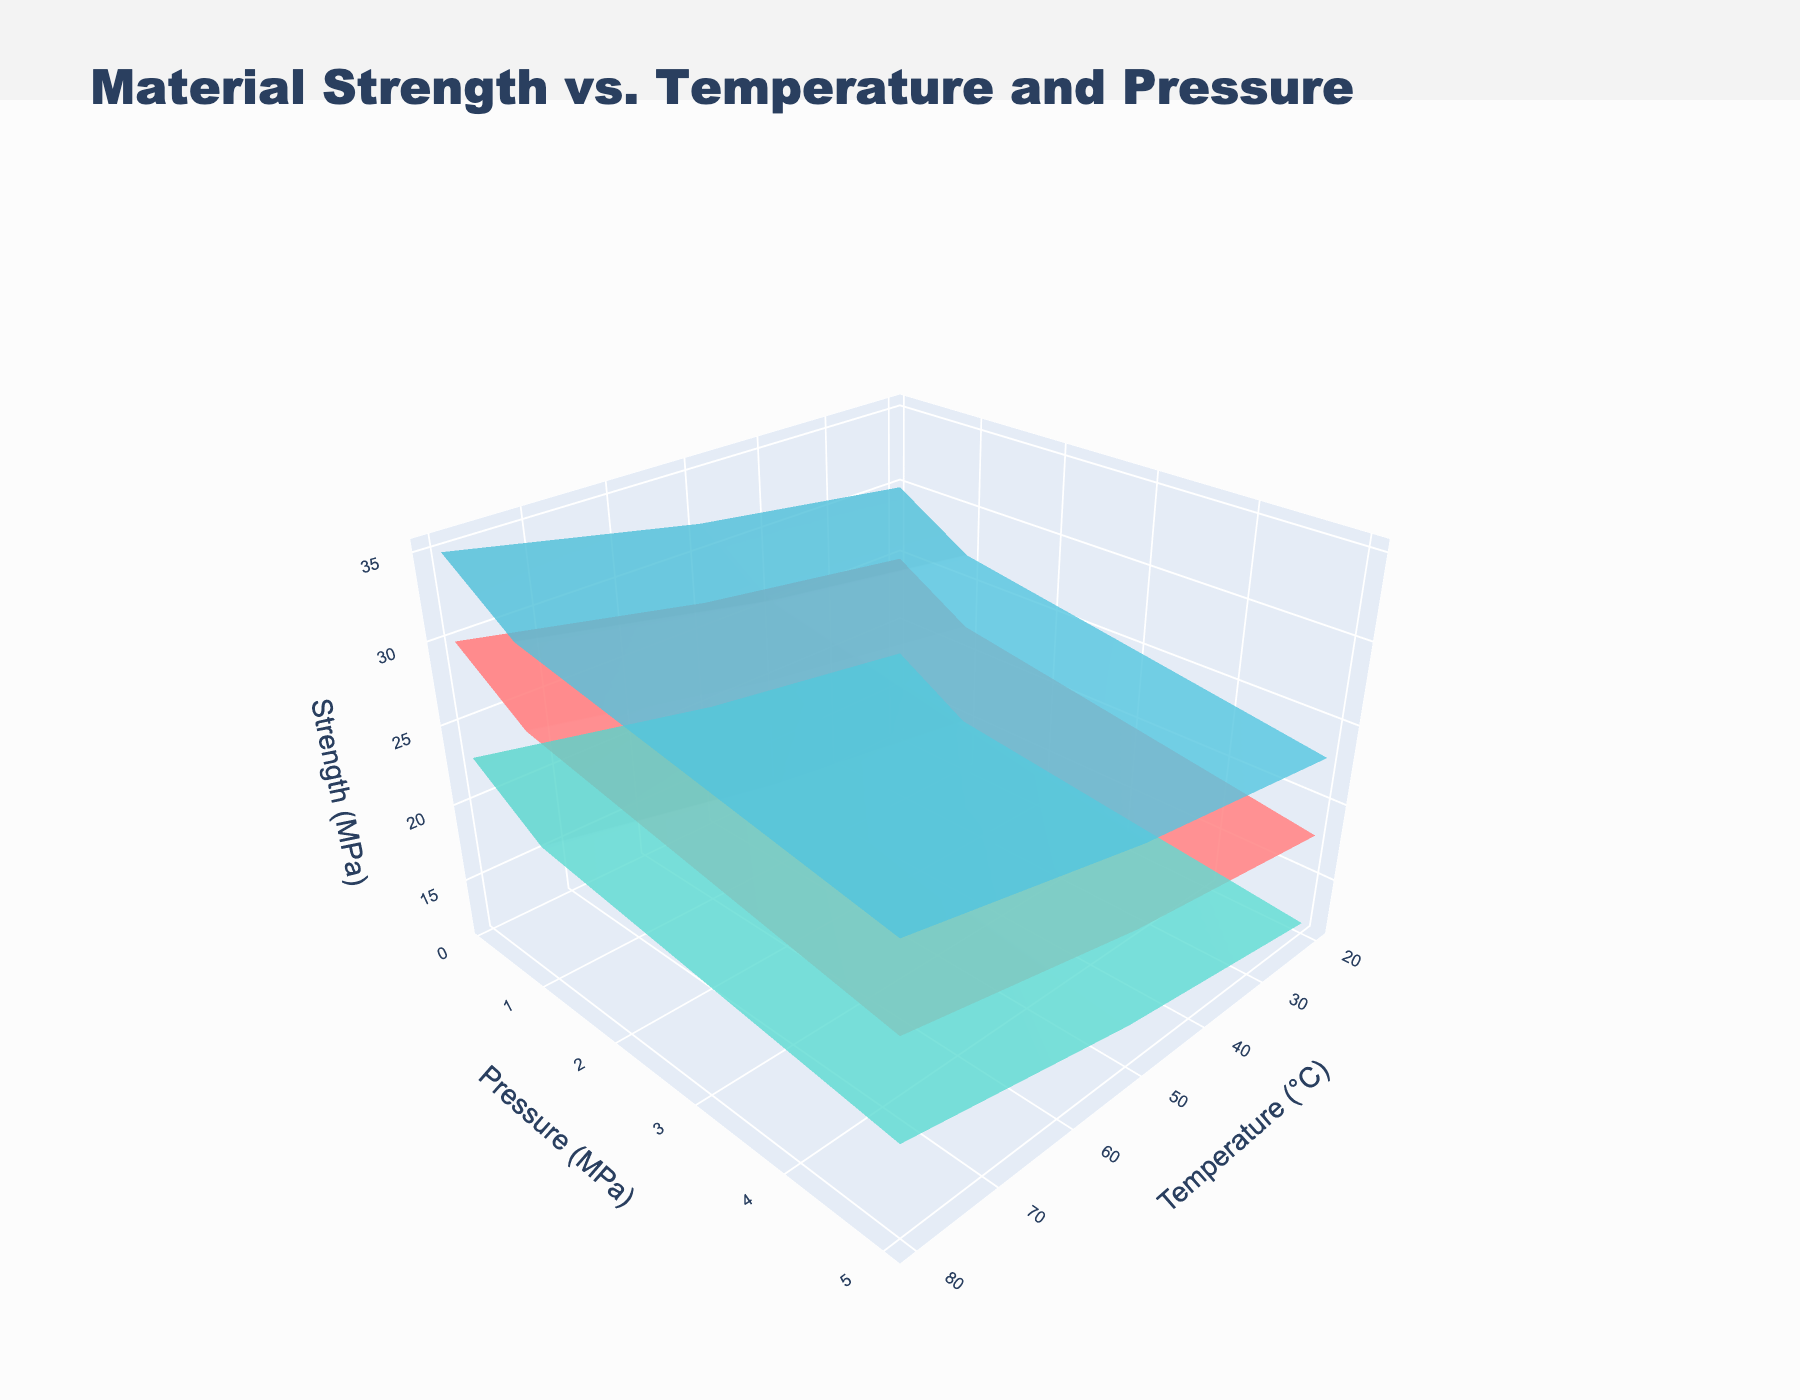What is the title of the plot? The title of the plot is located at the top of the figure; it summarizes the main idea of the visual representation. The text of the title in this plot is 'Material Strength vs. Temperature and Pressure'.
Answer: Material Strength vs. Temperature and Pressure How many distinct materials are displayed in the plot? Looking at the legend or the different color palettes in the plot, the figure displays three distinct materials.
Answer: 3 Which material shows the highest strength at 20°C and 0.1 MPa? By examining the section of the plot where Temperature = 20°C and Pressure = 0.1 MPa, we can see that the highest strength is exhibited by Recycled ABS.
Answer: Recycled ABS What material exhibits the greatest reduction in strength when temperature increases from 20°C to 80°C at 0.1 MPa pressure? For each material, compare the strength values at 20°C and 80°C under 0.1 MPa pressure. The strength reduction can be calculated as 25 to 18 for Recycled PET, 18 to 12 for Recycled HDPE, and 30 to 23 for Recycled ABS. Recycled HDPE shows the largest reduction (from 18 to 12 MPa).
Answer: Recycled HDPE At what temperature and pressure does Recycled PET have a strength of 22 MPa? By locating the specific surface for Recycled PET in the plot, we see that at a temperature of 50°C and pressure of 0.1 MPa, the material strength is 22 MPa.
Answer: 50°C and 0.1 MPa Which material's strength is most affected by changes in pressure at 50°C? Observing the plot for variations at 50°C across different pressures, Recycled ABS shows a larger range from 27 MPa to 32 MPa, compared to Recycled PET (22 MPa to 27 MPa) and Recycled HDPE (15 MPa to 20 MPa). Thus, Recycled ABS strength is most affected.
Answer: Recycled ABS What is the difference in strength between Recycled PET and Recycled HDPE at 80°C and 5 MPa pressure? Locate the z-axis values for both materials at 80°C and 5 MPa, Recycled PET has a strength of 23 MPa and Recycled HDPE has a strength of 17 MPa. The difference is 23 MPa - 17 MPa.
Answer: 6 MPa If we increase the temperature from 20°C to 50°C under a pressure of 5 MPa, which material shows the smallest decrease in strength? Compare the strength values at 20°C to 50°C for all materials under 5 MPa. Recycled PET decreases from 30 MPa to 27 MPa (3 MPa), Recycled HDPE from 23 MPa to 20 MPa (3 MPa), and Recycled ABS from 35 MPa to 32 MPa (3 MPa). All materials show the same decrease.
Answer: All materials (3 MPa) Which material consistently shows higher strength values across all temperatures and pressures? By examining the surfaces of all materials in the figure, we can see that Recycled ABS consistently has higher strength values across the entire range of temperatures and pressures compared to Recycled PET and Recycled HDPE.
Answer: Recycled ABS 